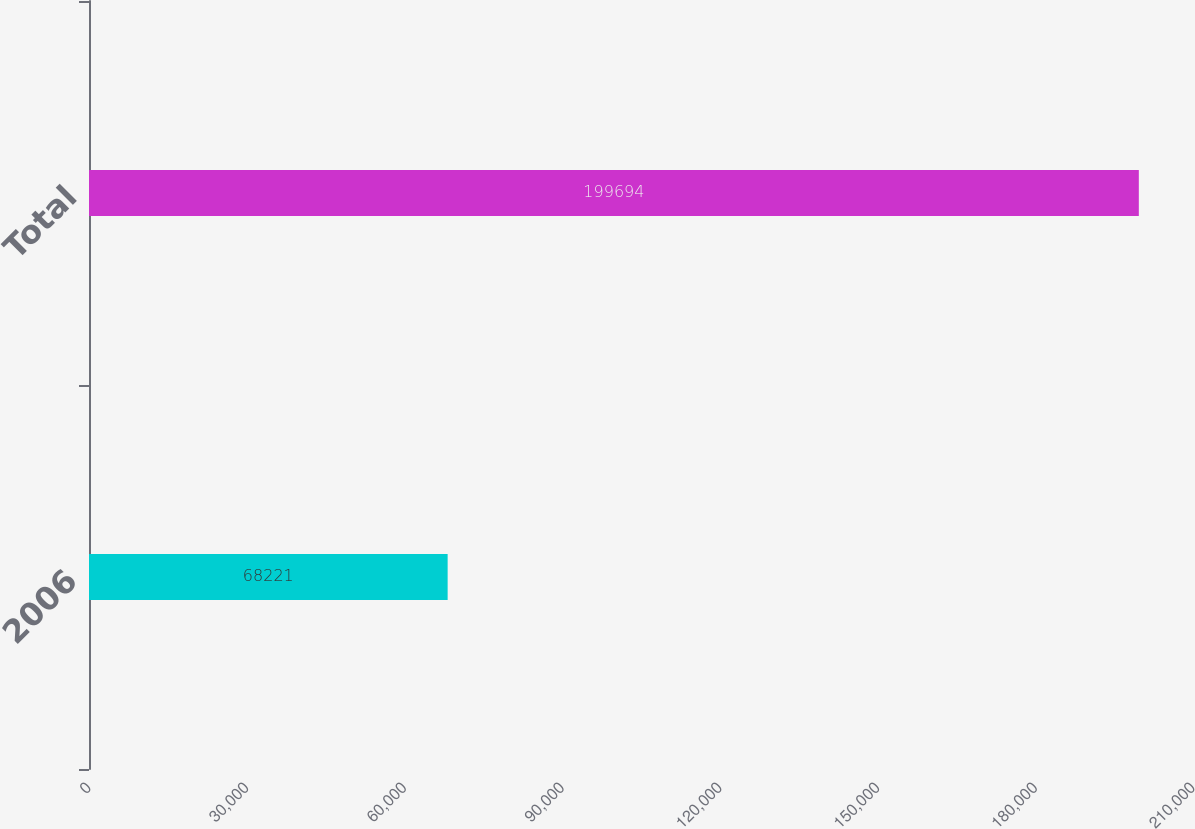Convert chart to OTSL. <chart><loc_0><loc_0><loc_500><loc_500><bar_chart><fcel>2006<fcel>Total<nl><fcel>68221<fcel>199694<nl></chart> 